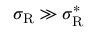<formula> <loc_0><loc_0><loc_500><loc_500>\sigma _ { R } \gg \sigma _ { R } ^ { * }</formula> 